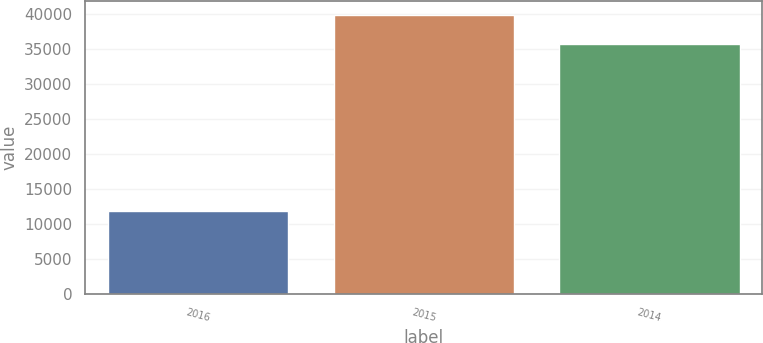Convert chart to OTSL. <chart><loc_0><loc_0><loc_500><loc_500><bar_chart><fcel>2016<fcel>2015<fcel>2014<nl><fcel>11924<fcel>39895<fcel>35663<nl></chart> 